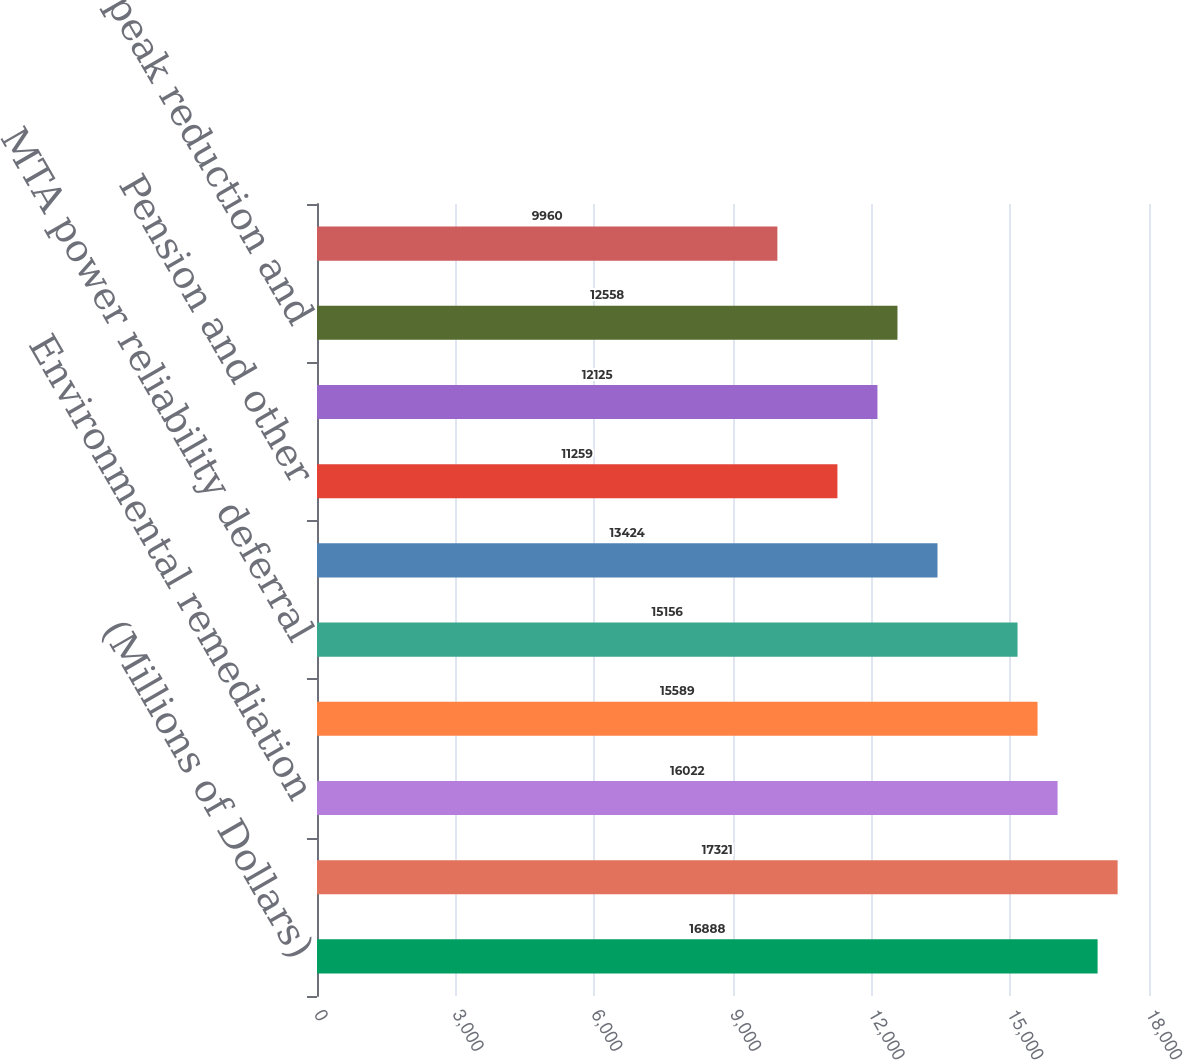Convert chart to OTSL. <chart><loc_0><loc_0><loc_500><loc_500><bar_chart><fcel>(Millions of Dollars)<fcel>Unrecognized pension and other<fcel>Environmental remediation<fcel>Revenue taxes<fcel>MTA power reliability deferral<fcel>Property tax reconciliation<fcel>Pension and other<fcel>Municipal infrastructure<fcel>System peak reduction and<fcel>Brooklyn Queens demand<nl><fcel>16888<fcel>17321<fcel>16022<fcel>15589<fcel>15156<fcel>13424<fcel>11259<fcel>12125<fcel>12558<fcel>9960<nl></chart> 